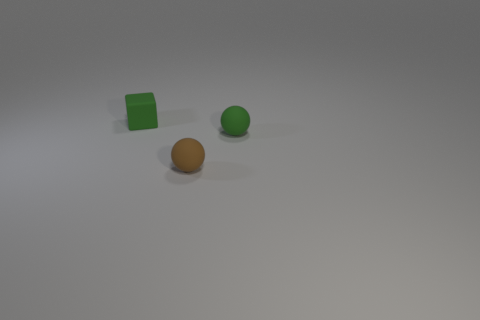Add 2 tiny rubber blocks. How many objects exist? 5 Subtract all cubes. How many objects are left? 2 Add 1 brown matte blocks. How many brown matte blocks exist? 1 Subtract 0 cyan spheres. How many objects are left? 3 Subtract all gray shiny cylinders. Subtract all tiny matte blocks. How many objects are left? 2 Add 1 balls. How many balls are left? 3 